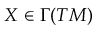<formula> <loc_0><loc_0><loc_500><loc_500>X \in \Gamma ( T M )</formula> 